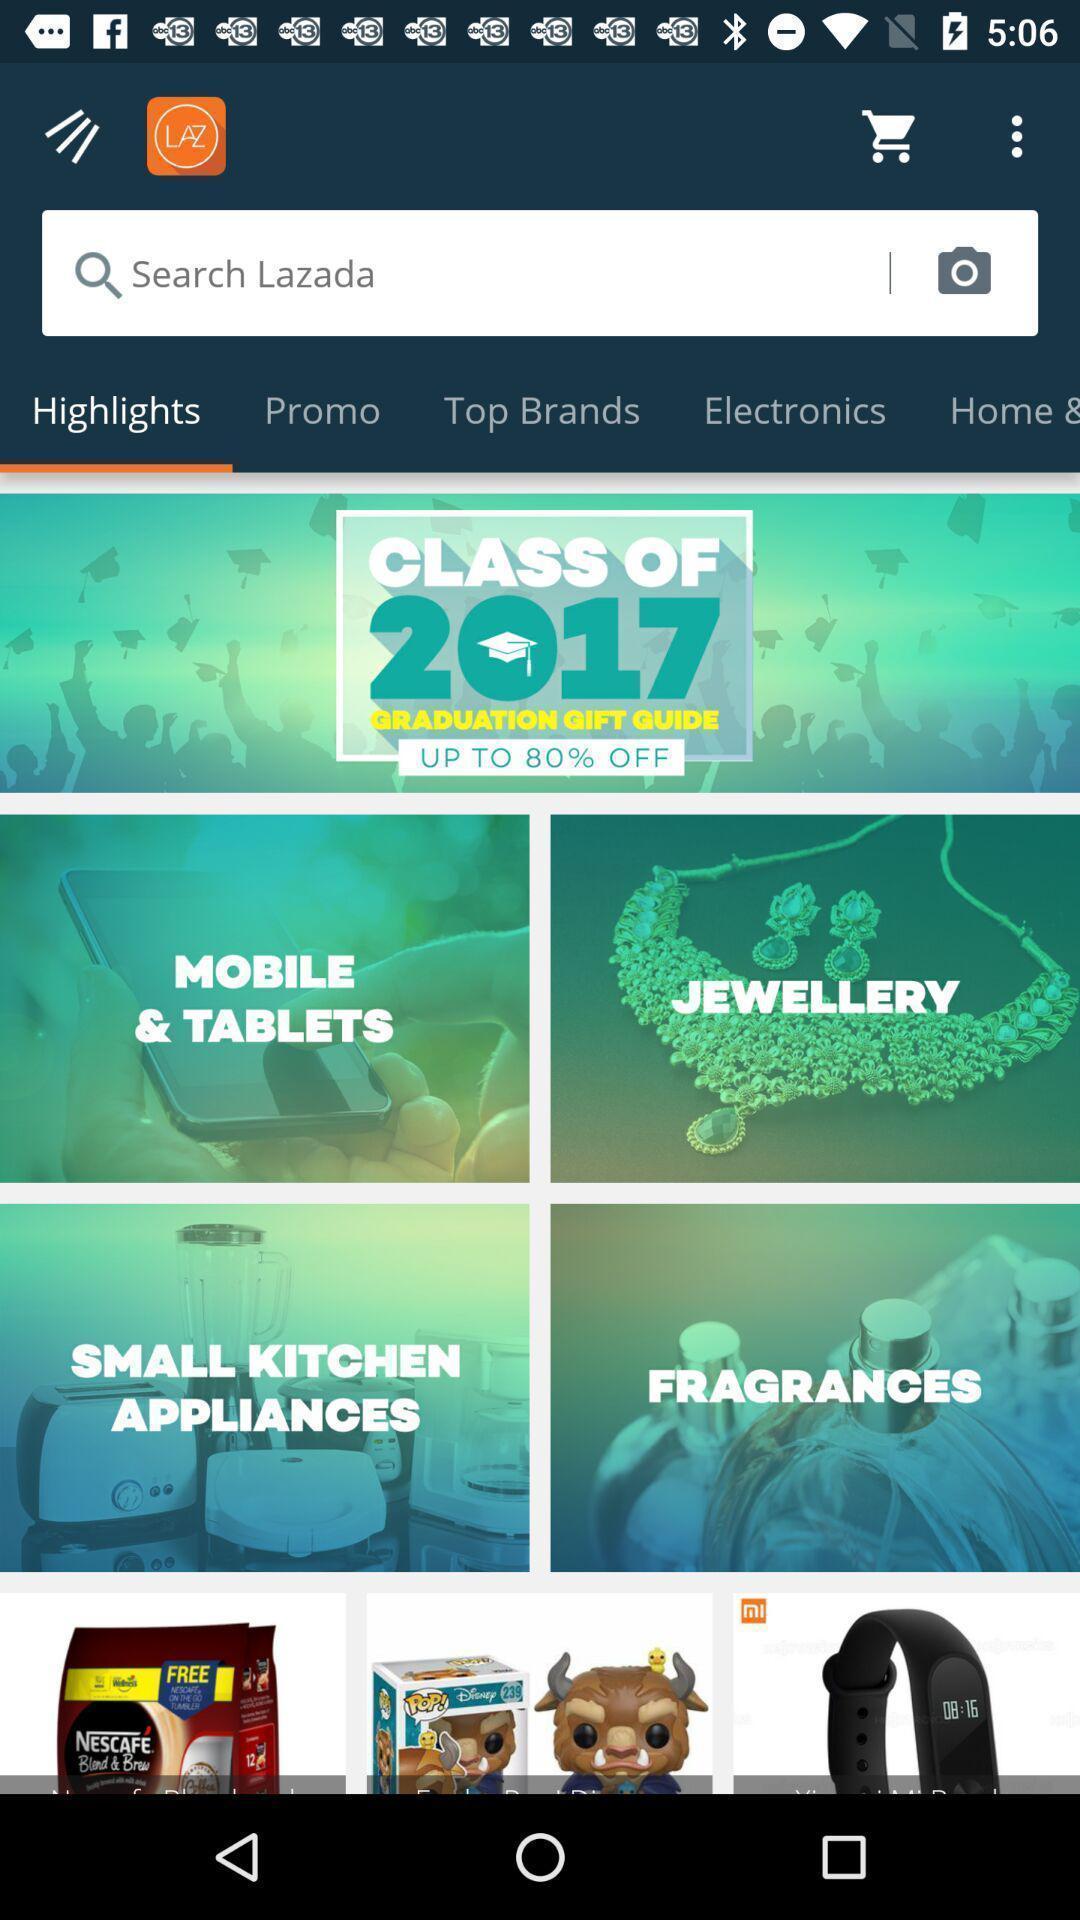Provide a description of this screenshot. Screen showing highlights with search bar. 